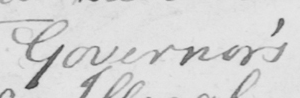Can you read and transcribe this handwriting? Governor ' s 